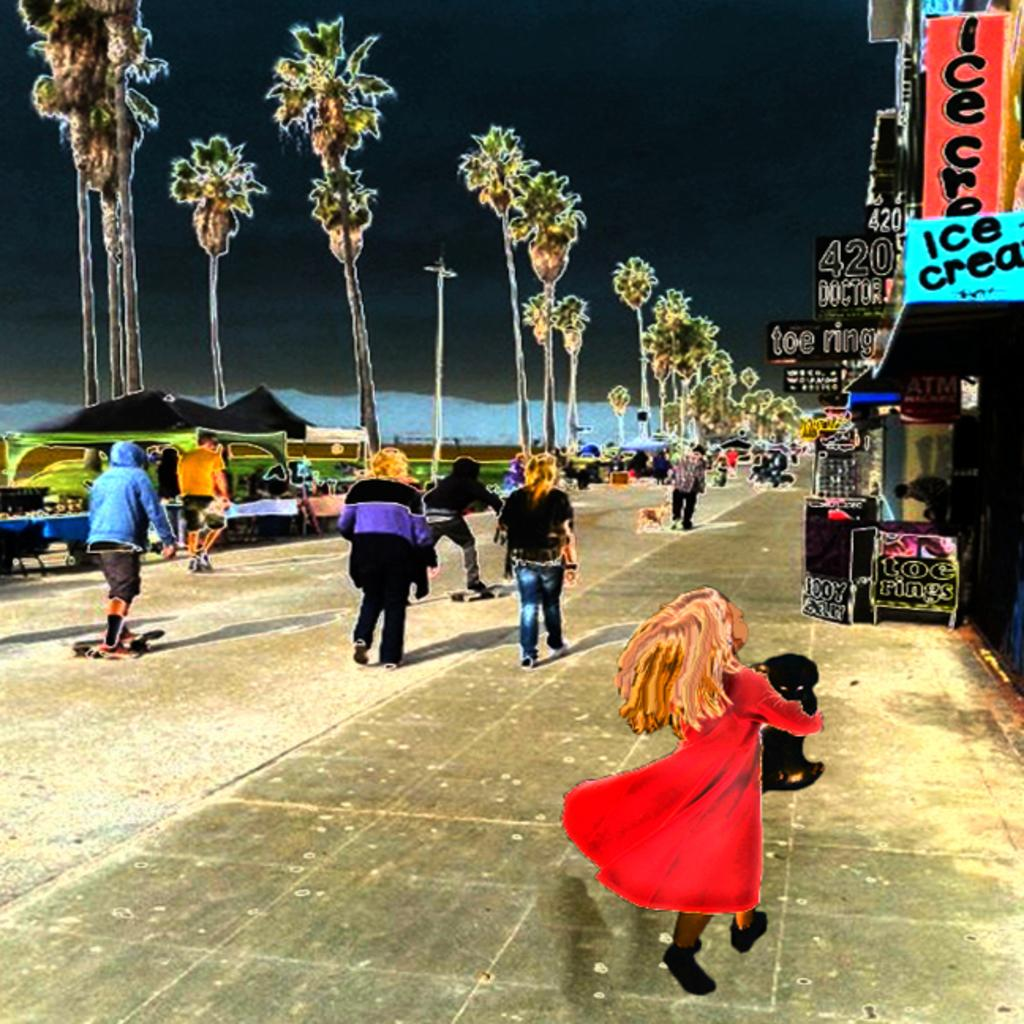Who or what can be seen in the image? There are people in the image. What type of natural elements are present in the image? There are trees in the image. What objects can be seen in the image? There are boards and a pole in the image. What type of establishments are visible in the image? There are stores in the image. What type of nerve is present in the image? There is no nerve present in the image. What type of government is depicted in the image? There is no government depicted in the image. 